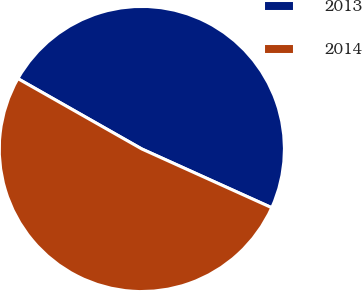<chart> <loc_0><loc_0><loc_500><loc_500><pie_chart><fcel>2013<fcel>2014<nl><fcel>48.54%<fcel>51.46%<nl></chart> 